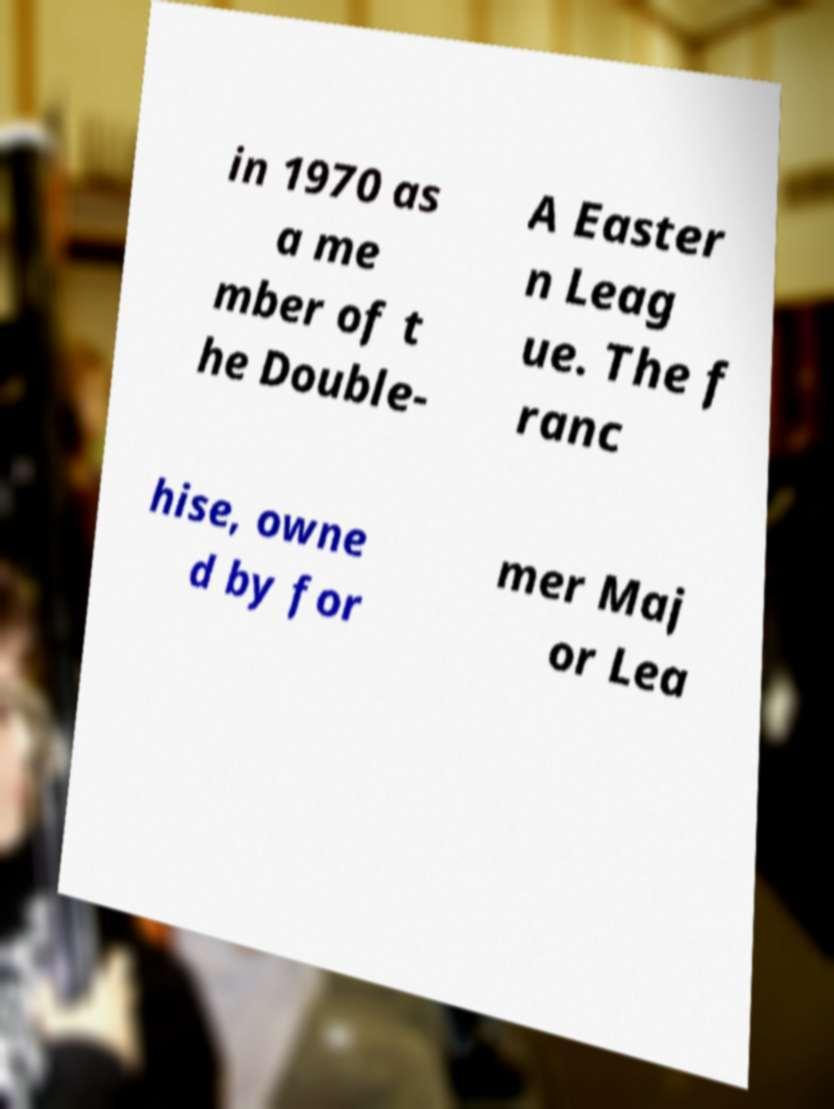Could you assist in decoding the text presented in this image and type it out clearly? in 1970 as a me mber of t he Double- A Easter n Leag ue. The f ranc hise, owne d by for mer Maj or Lea 